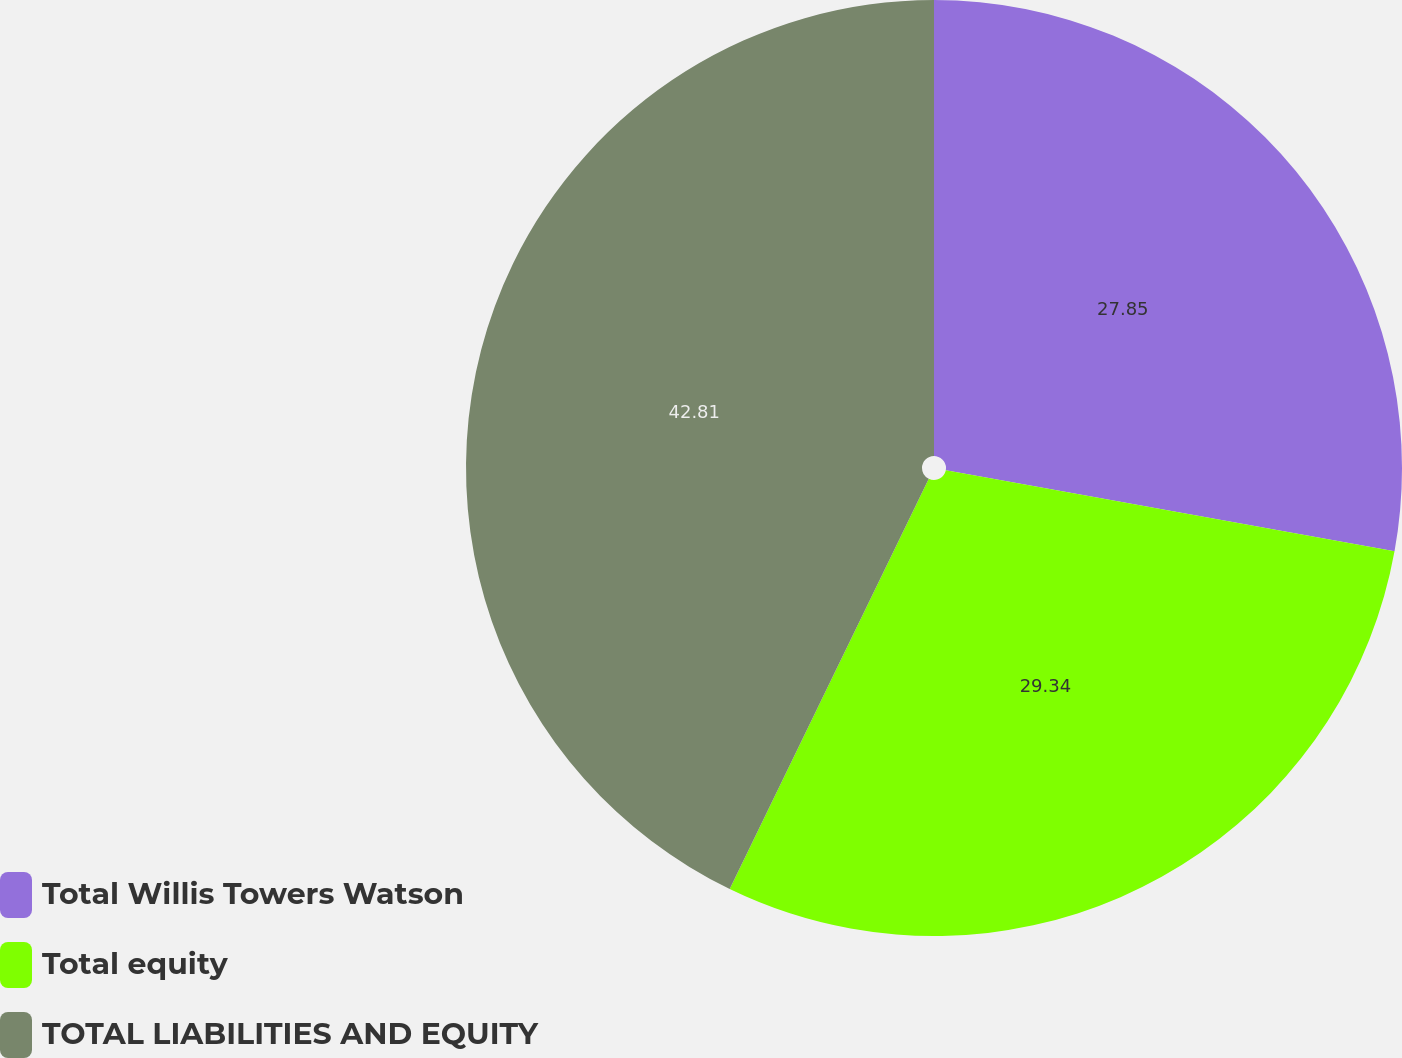<chart> <loc_0><loc_0><loc_500><loc_500><pie_chart><fcel>Total Willis Towers Watson<fcel>Total equity<fcel>TOTAL LIABILITIES AND EQUITY<nl><fcel>27.85%<fcel>29.34%<fcel>42.81%<nl></chart> 